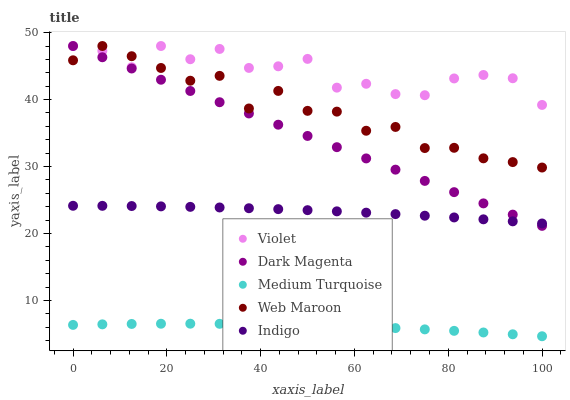Does Medium Turquoise have the minimum area under the curve?
Answer yes or no. Yes. Does Violet have the maximum area under the curve?
Answer yes or no. Yes. Does Web Maroon have the minimum area under the curve?
Answer yes or no. No. Does Web Maroon have the maximum area under the curve?
Answer yes or no. No. Is Dark Magenta the smoothest?
Answer yes or no. Yes. Is Violet the roughest?
Answer yes or no. Yes. Is Web Maroon the smoothest?
Answer yes or no. No. Is Web Maroon the roughest?
Answer yes or no. No. Does Medium Turquoise have the lowest value?
Answer yes or no. Yes. Does Web Maroon have the lowest value?
Answer yes or no. No. Does Violet have the highest value?
Answer yes or no. Yes. Does Medium Turquoise have the highest value?
Answer yes or no. No. Is Medium Turquoise less than Dark Magenta?
Answer yes or no. Yes. Is Web Maroon greater than Indigo?
Answer yes or no. Yes. Does Web Maroon intersect Dark Magenta?
Answer yes or no. Yes. Is Web Maroon less than Dark Magenta?
Answer yes or no. No. Is Web Maroon greater than Dark Magenta?
Answer yes or no. No. Does Medium Turquoise intersect Dark Magenta?
Answer yes or no. No. 